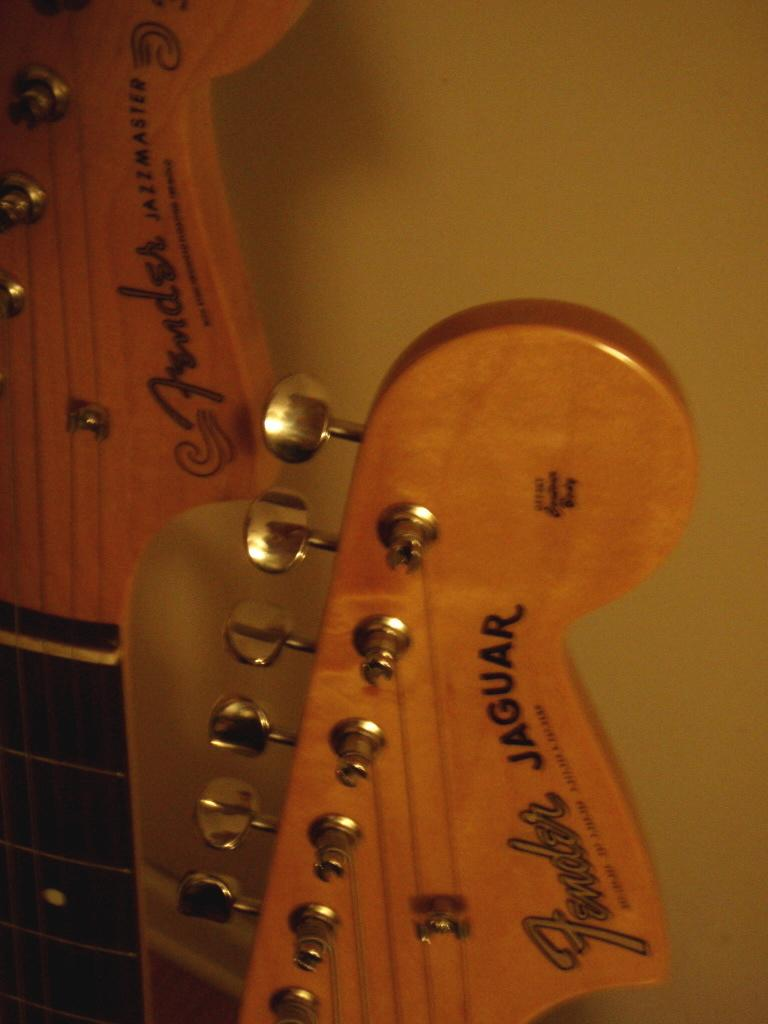What type of object is the main subject in the image? There is a musical instrument in the image. Where can the bells be found in the image? There are no bells present in the image. What type of underground storage space is depicted in the image? The image does not show any cellar or underground storage space. 